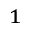Convert formula to latex. <formula><loc_0><loc_0><loc_500><loc_500>^ { 1 }</formula> 